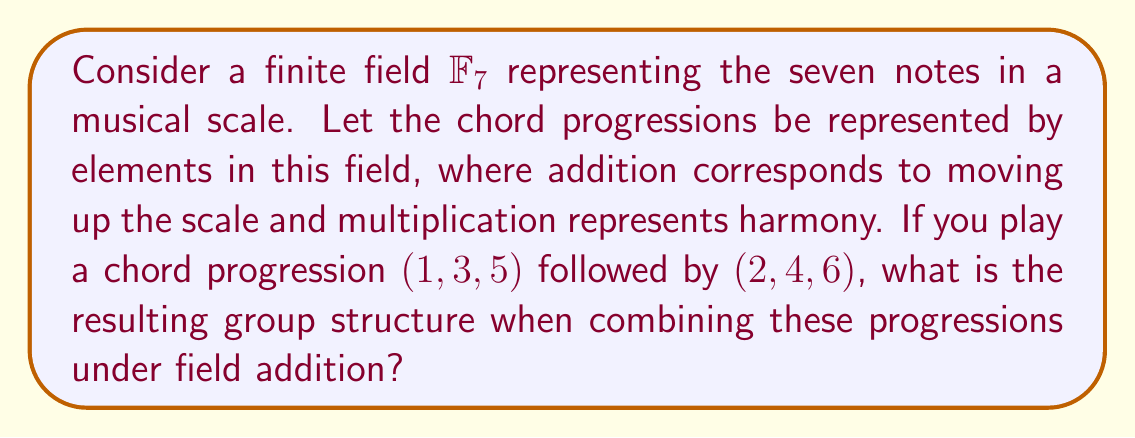Give your solution to this math problem. Let's approach this step-by-step:

1) First, we need to understand that we're working in $\mathbb{F}_7$, which means all operations are performed modulo 7.

2) We have two chord progressions: $(1, 3, 5)$ and $(2, 4, 6)$.

3) To combine these under field addition, we add the corresponding elements:

   $$(1, 3, 5) + (2, 4, 6) = (1+2, 3+4, 5+6)$$

4) Now, let's perform these additions in $\mathbb{F}_7$:

   $1 + 2 = 3$
   $3 + 4 = 7 \equiv 0 \pmod{7}$
   $5 + 6 = 11 \equiv 4 \pmod{7}$

5) Therefore, the resulting progression is $(3, 0, 4)$.

6) To analyze the group structure, we need to consider all possible combinations of these progressions under addition. The set of all such combinations forms a subgroup of $(\mathbb{F}_7^3, +)$.

7) This subgroup is generated by $(1, 3, 5)$ and $(2, 4, 6)$. It's easy to verify that repeated addition of these elements will generate all elements of the form $(a, b, c)$ where $a, b, c \in \mathbb{F}_7$.

8) Therefore, the resulting group structure is isomorphic to $\mathbb{F}_7^3$, which is an elementary abelian 7-group of order $7^3 = 343$.
Answer: $\mathbb{F}_7^3$ 